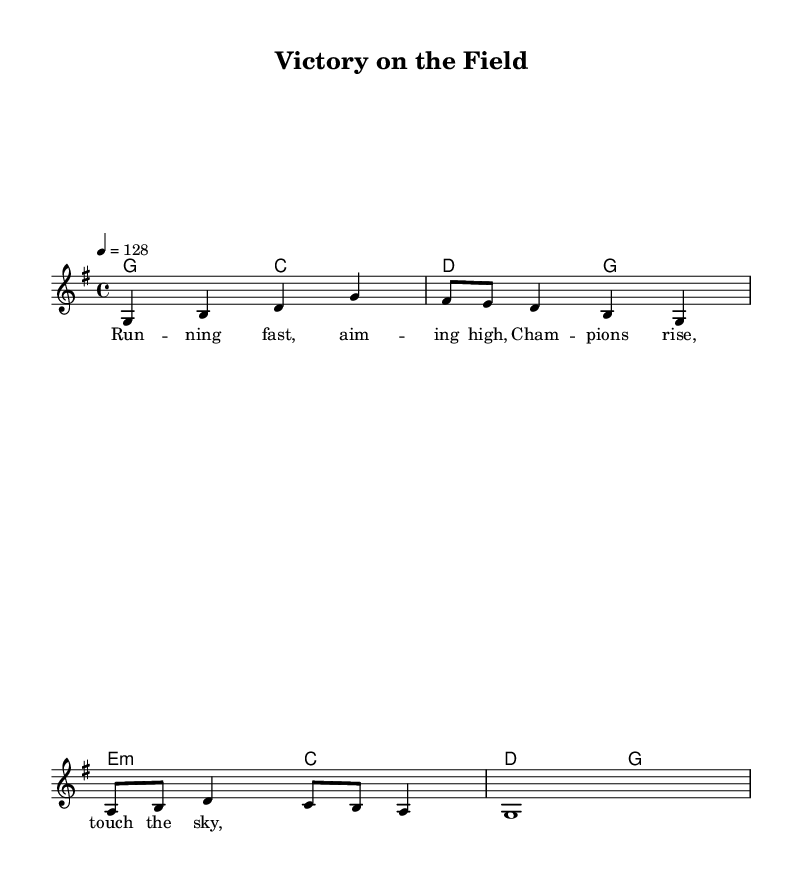What is the key signature of this music? The key signature is G major, which has one sharp (F#). This can be determined by looking at the key signature indication in the music sheet which is represented before the time signature.
Answer: G major What is the time signature of this music? The time signature is 4/4, which indicates four beats per measure and a quarter note gets one beat. This is visible at the beginning of the sheet music after the key signature.
Answer: 4/4 What is the tempo marking for this piece? The tempo marking is quarter note = 128, which states that each quarter note should be played at a pace of 128 beats per minute. This is indicated right after the time signature at the top of the score.
Answer: 128 How many measures are there in the melody? There are four measures in the melody, as indicated by the grouping of notes and the bar lines separating them. Counting the sections between the bar lines confirms this.
Answer: 4 What type of chords are primarily used in the harmonies? The primary chords used in the harmonies are major chords, which can be identified by looking at the chord symbols that accompany the harmonies throughout the piece. The harmony reflects common major triads such as G major and C major.
Answer: Major What theme is presented in the lyrics of the song? The theme presented in the lyrics is athletic achievement and sportsmanship, emphasizing running fast and becoming champions. This thematic content can be inferred from the phrases noted in the lyrics section related to striving for victory.
Answer: Athletic achievement What is the form of the music based on the score? The form of the music is a simple verse structure, as evidenced by the presence of the verse lyrics which suggest a repetitive or straightforward progression in terms of lyrical narrative.
Answer: Verse 